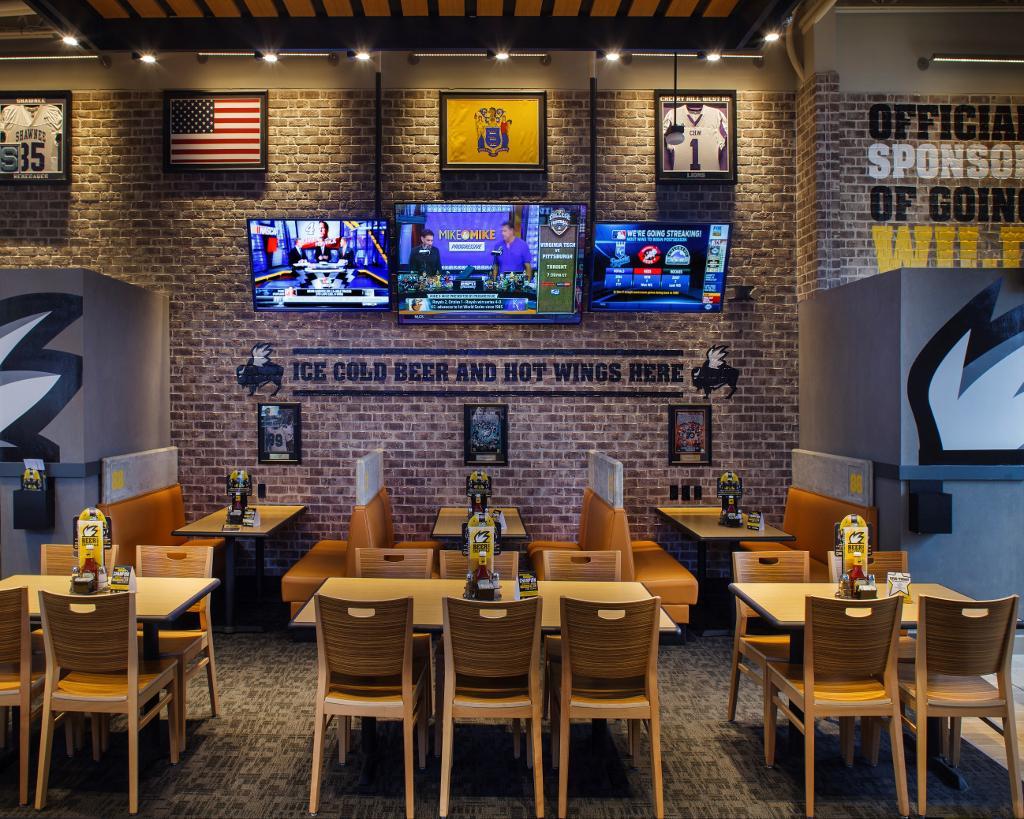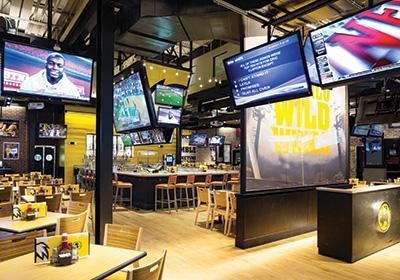The first image is the image on the left, the second image is the image on the right. Analyze the images presented: Is the assertion "There are no people in either image." valid? Answer yes or no. Yes. 